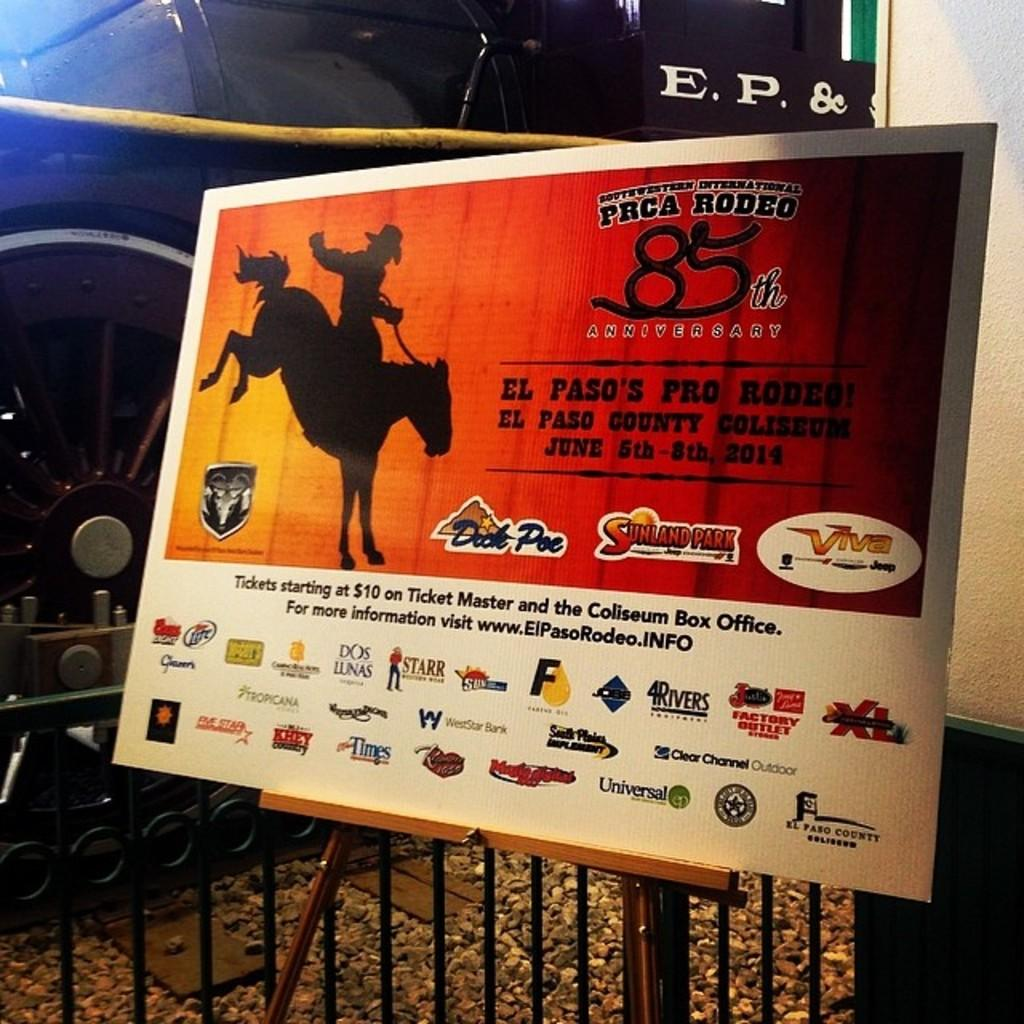<image>
Offer a succinct explanation of the picture presented. A poster advertises a local rodeo's 85th anniversary event. 